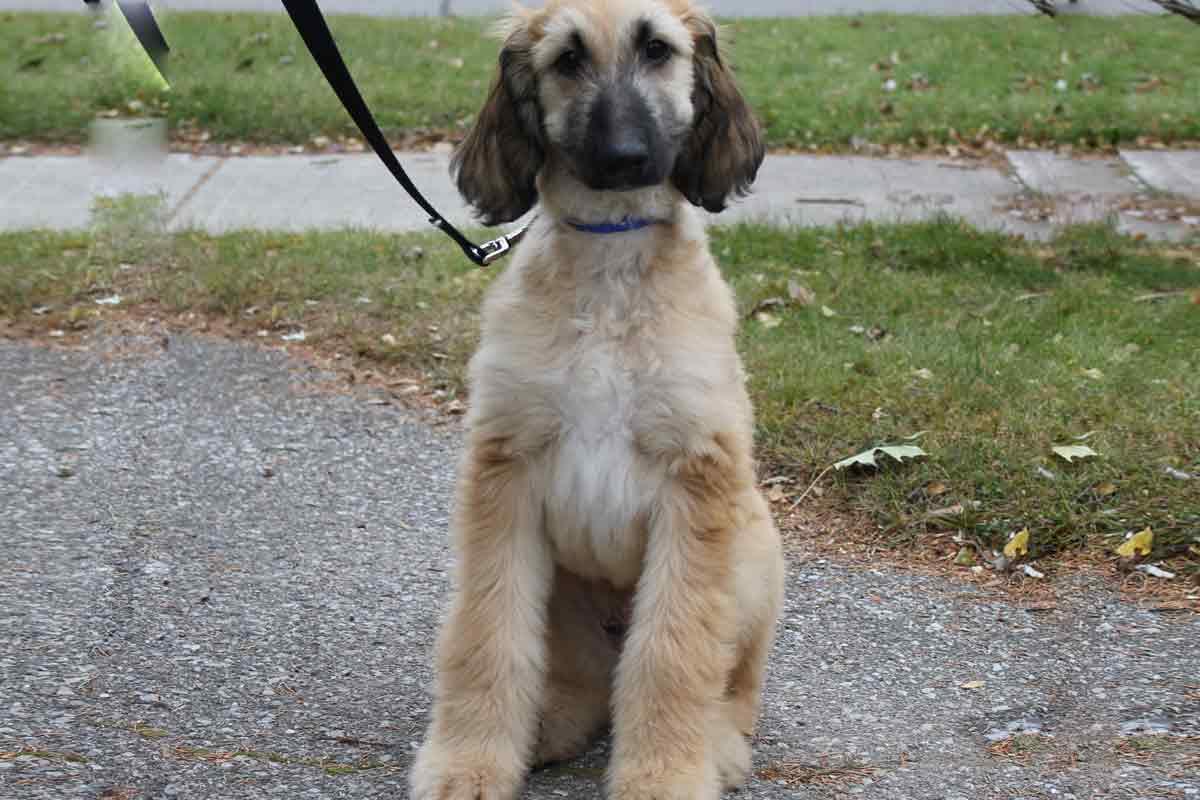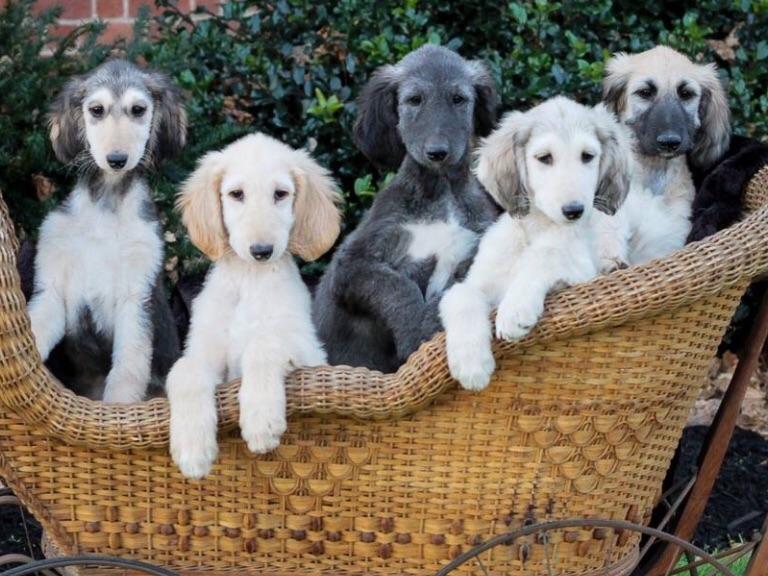The first image is the image on the left, the second image is the image on the right. Considering the images on both sides, is "There is a group of dogs in one of the images." valid? Answer yes or no. Yes. The first image is the image on the left, the second image is the image on the right. Examine the images to the left and right. Is the description "One image contains at least five dogs, with varying fur coloration." accurate? Answer yes or no. Yes. 